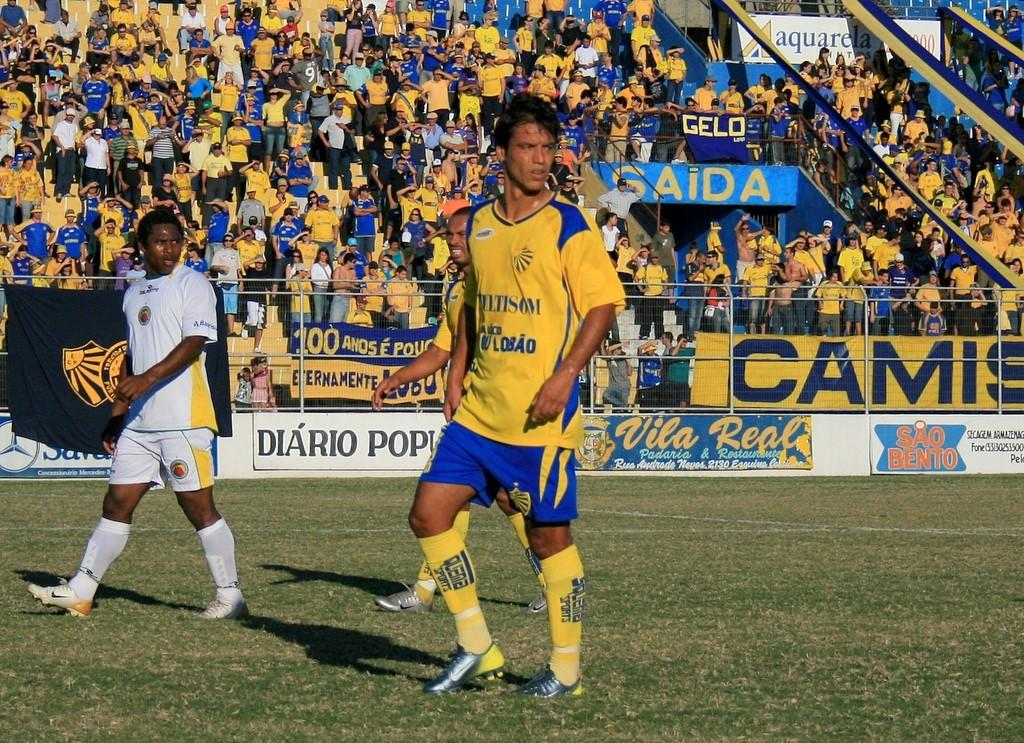<image>
Offer a succinct explanation of the picture presented. soccer players on a field with ads for Vila Real 